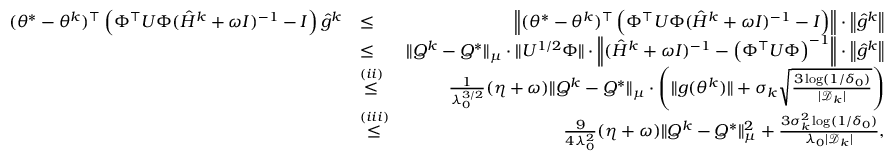<formula> <loc_0><loc_0><loc_500><loc_500>\begin{array} { r l r } { ( \theta ^ { * } - \theta ^ { k } ) ^ { \top } \left ( \Phi ^ { \top } U \Phi ( \hat { H } ^ { k } + \omega I ) ^ { - 1 } - I \right ) \hat { g } ^ { k } } & { \leq } & { \left \| ( \theta ^ { * } - \theta ^ { k } ) ^ { \top } \left ( \Phi ^ { \top } U \Phi ( \hat { H } ^ { k } + \omega I ) ^ { - 1 } - I \right ) \right \| \cdot \left \| \hat { g } ^ { k } \right \| } \\ & { \leq } & { \| Q ^ { k } - Q ^ { * } \| _ { \mu } \cdot \| U ^ { 1 / 2 } \Phi \| \cdot \left \| ( \hat { H } ^ { k } + \omega I ) ^ { - 1 } - \left ( \Phi ^ { \top } U \Phi \right ) ^ { - 1 } \right \| \cdot \left \| \hat { g } ^ { k } \right \| } \\ & { \overset { ( i i ) } { \leq } } & { \frac { 1 } { \lambda _ { 0 } ^ { 3 / 2 } } ( \eta + \omega ) \| Q ^ { k } - Q ^ { * } \| _ { \mu } \cdot \left ( \| g ( \theta ^ { k } ) \| + \sigma _ { k } \sqrt { \frac { 3 \log ( 1 / \delta _ { 0 } ) } { | \mathcal { D } _ { k } | } } \right ) } \\ & { \overset { ( i i i ) } { \leq } } & { \frac { 9 } { 4 \lambda _ { 0 } ^ { 2 } } ( \eta + \omega ) \| Q ^ { k } - Q ^ { * } \| _ { \mu } ^ { 2 } + \frac { 3 \sigma _ { k } ^ { 2 } \log ( 1 / \delta _ { 0 } ) } { \lambda _ { 0 } | \mathcal { D } _ { k } | } , } \end{array}</formula> 